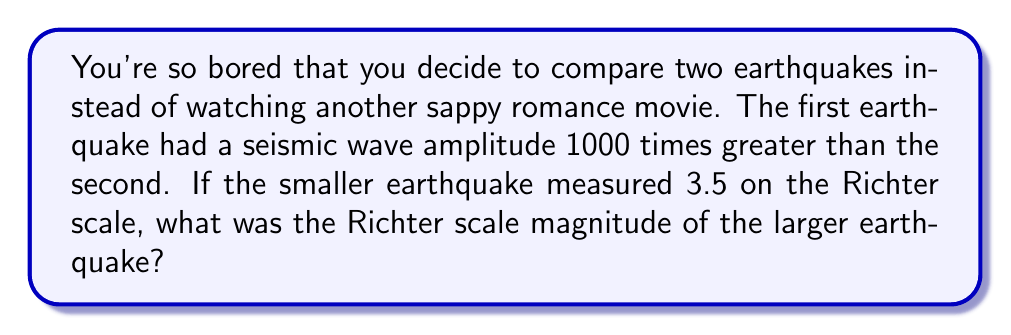Provide a solution to this math problem. Let's approach this step-by-step using the Richter scale formula:

1) The Richter scale is logarithmic and is defined by the equation:

   $$M = \log_{10}(A) + C$$

   Where $M$ is the magnitude, $A$ is the amplitude of the seismic waves, and $C$ is a constant that depends on the distance of the seismometer from the earthquake.

2) We're told that the first earthquake had an amplitude 1000 times greater than the second. Let's call the amplitude of the smaller earthquake $A_2$ and the larger one $A_1$. So:

   $$A_1 = 1000A_2$$

3) We know the magnitude of the smaller earthquake is 3.5. Let's call the magnitude of the larger earthquake $M_1$. We can set up two equations:

   $$3.5 = \log_{10}(A_2) + C$$
   $$M_1 = \log_{10}(A_1) + C$$

4) Subtracting these equations eliminates the constant $C$:

   $$M_1 - 3.5 = \log_{10}(A_1) - \log_{10}(A_2)$$

5) Using the logarithm property $\log_a(x) - \log_a(y) = \log_a(\frac{x}{y})$, we get:

   $$M_1 - 3.5 = \log_{10}(\frac{A_1}{A_2}) = \log_{10}(1000) = 3$$

6) Solving for $M_1$:

   $$M_1 = 3.5 + 3 = 6.5$$

Therefore, the magnitude of the larger earthquake on the Richter scale is 6.5.
Answer: 6.5 